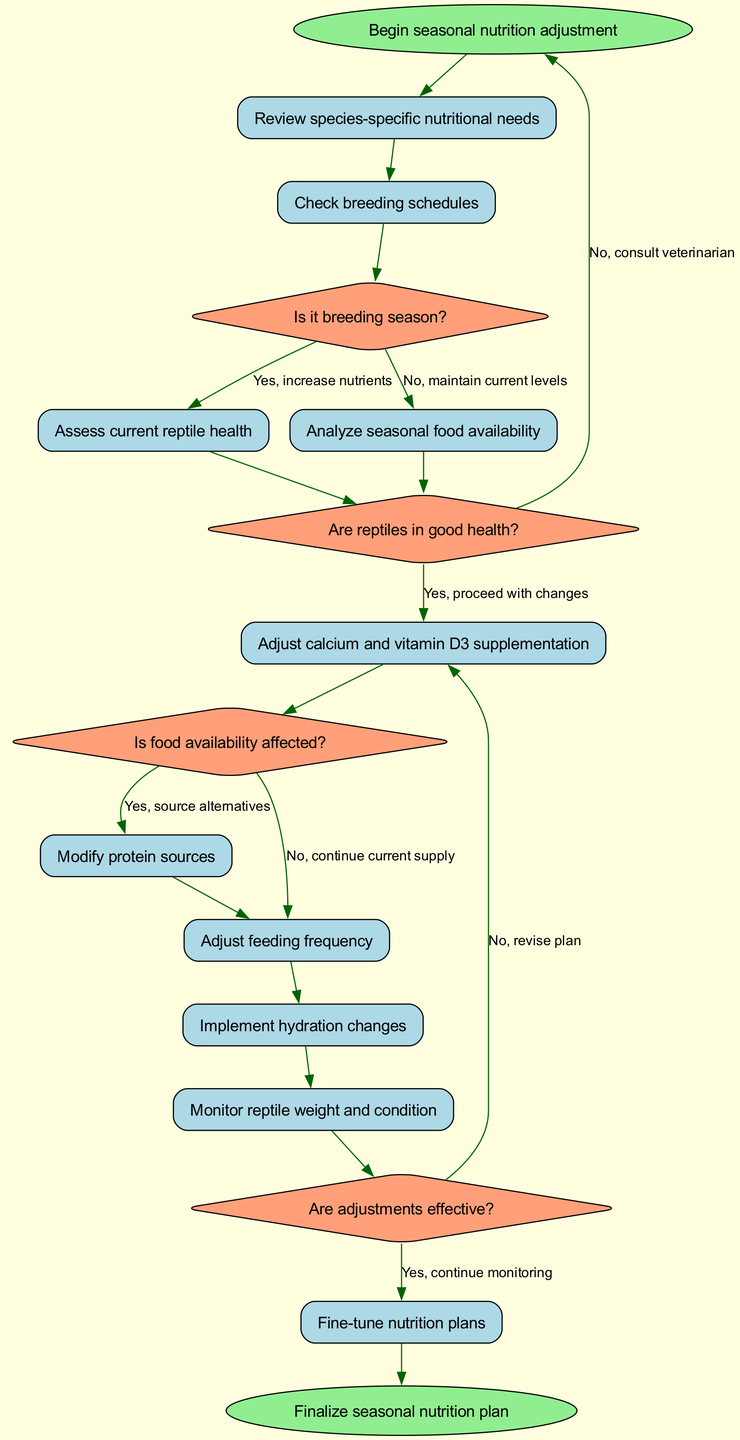What is the start node of the diagram? The start node is labeled as "Begin seasonal nutrition adjustment." This is the initial point in the activity diagram from which all activities begin.
Answer: Begin seasonal nutrition adjustment How many decision nodes are present in the diagram? There are four decision nodes in the diagram as indicated by the diamond shapes, each representing a decision point before moving to the next actions.
Answer: 4 What is the first activity after the start node? The first activity following the start node is "Review species-specific nutritional needs." This is the first step to be executed after beginning the seasonal nutrition adjustment process.
Answer: Review species-specific nutritional needs If a reptile is not in good health, what should be done next according to the diagram? If reptiles are not in good health, the flow leads back to the start node as indicated by the edge connected to it, suggesting to consult a veterinarian instead of proceeding further with adjustments.
Answer: Consult veterinarian What happens if food availability is affected? If food availability is affected, the next step is to "Source alternatives," indicating a need for alternative food sources, as per the decision flow in the diagram.
Answer: Source alternatives How many activities are listed in the diagram? There are ten activities outlined in the diagram, each representing a step in the process of adjusting nutrition plans for reptiles.
Answer: 10 What is the final node of the diagram? The final node of the diagram is labeled as "Finalize seasonal nutrition plan," which signifies the completion of the seasonal nutrition adjustment process.
Answer: Finalize seasonal nutrition plan What is done after adjusting the calcium and vitamin D3 supplementation? After adjusting calcium and vitamin D3 supplementation, the next activities involve modifying protein sources and adjusting feeding frequency, showcasing a continuous flow of activities after supplementation adjustments.
Answer: Modify protein sources What should be done if adjustments are not effective? If the adjustments are not found to be effective based on monitoring, the flow will revert to revising the plan as indicated in the decision node for effectiveness.
Answer: Revise plan 